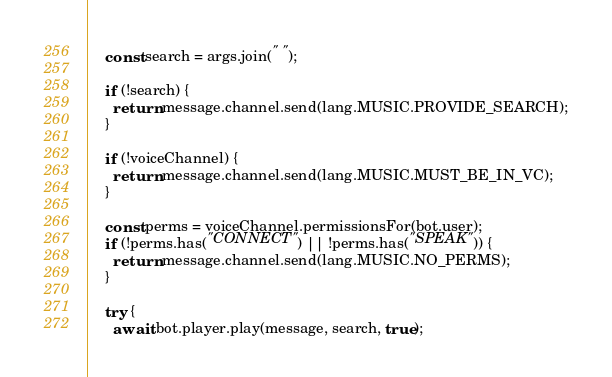Convert code to text. <code><loc_0><loc_0><loc_500><loc_500><_JavaScript_>    const search = args.join(" ");

    if (!search) {
      return message.channel.send(lang.MUSIC.PROVIDE_SEARCH);
    }

    if (!voiceChannel) {
      return message.channel.send(lang.MUSIC.MUST_BE_IN_VC);
    }

    const perms = voiceChannel.permissionsFor(bot.user);
    if (!perms.has("CONNECT") || !perms.has("SPEAK")) {
      return message.channel.send(lang.MUSIC.NO_PERMS);
    }

    try {
      await bot.player.play(message, search, true);</code> 